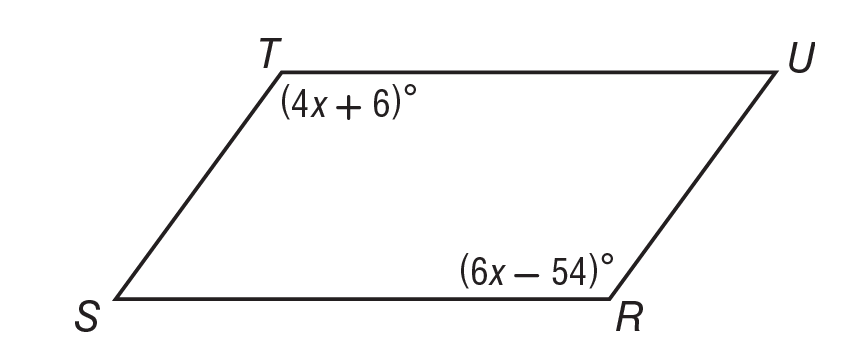Answer the mathemtical geometry problem and directly provide the correct option letter.
Question: Solve for x in parallelogram R S T U.
Choices: A: 12 B: 18 C: 25 D: 30 D 